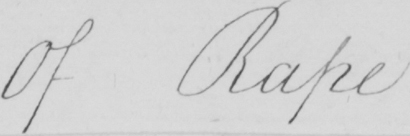Can you read and transcribe this handwriting? Of Rape . 